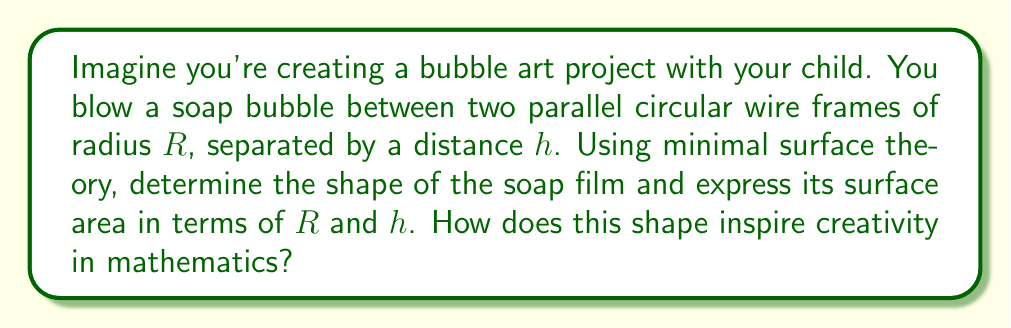Could you help me with this problem? Let's approach this step-by-step:

1) The soap film will form a surface of revolution called a catenoid, which is a minimal surface.

2) The equation of the generating curve (catenary) in the xz-plane is:

   $$z = a \cosh(\frac{x}{a})$$

   where $a$ is a constant to be determined.

3) The boundary conditions are:
   At $x = 0$, $z = \frac{h}{2}$
   At $x = \pm R$, $z = 0$

4) Applying these conditions:

   $$\frac{h}{2} = a \cosh(0) = a$$
   $$0 = a \cosh(\frac{R}{a})$$

5) From the second equation:

   $$\cosh(\frac{R}{a}) = \frac{h}{2a}$$

6) This transcendental equation determines $a$. It can be solved numerically.

7) The surface area of a catenoid is given by:

   $$A = 2\pi a^2 [\sinh(\frac{R}{a}) - \frac{R}{a}]$$

8) This shape inspires creativity by showing how complex mathematical concepts can produce beautiful, natural forms. The catenoid's elegant curve emerges from minimizing surface area, demonstrating the harmony between mathematical principles and physical phenomena.
Answer: Surface area: $A = 2\pi a^2 [\sinh(\frac{R}{a}) - \frac{R}{a}]$, where $a = \frac{h}{2}$ and $\cosh(\frac{R}{a}) = \frac{h}{2a}$ 